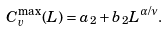Convert formula to latex. <formula><loc_0><loc_0><loc_500><loc_500>C _ { v } ^ { \max } ( L ) = a _ { 2 } + b _ { 2 } L ^ { \alpha / \nu } .</formula> 